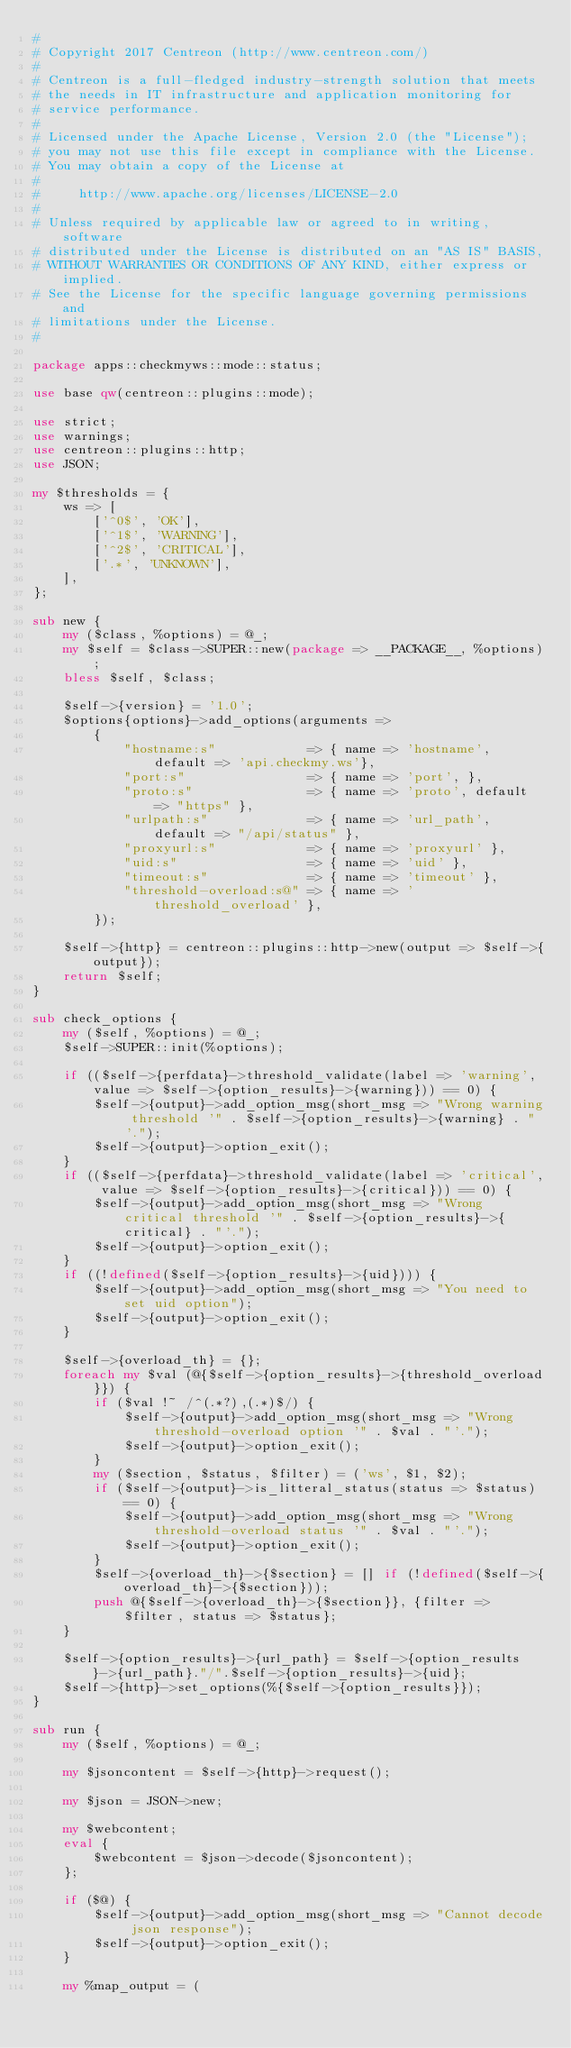Convert code to text. <code><loc_0><loc_0><loc_500><loc_500><_Perl_>#
# Copyright 2017 Centreon (http://www.centreon.com/)
#
# Centreon is a full-fledged industry-strength solution that meets
# the needs in IT infrastructure and application monitoring for
# service performance.
#
# Licensed under the Apache License, Version 2.0 (the "License");
# you may not use this file except in compliance with the License.
# You may obtain a copy of the License at
#
#     http://www.apache.org/licenses/LICENSE-2.0
#
# Unless required by applicable law or agreed to in writing, software
# distributed under the License is distributed on an "AS IS" BASIS,
# WITHOUT WARRANTIES OR CONDITIONS OF ANY KIND, either express or implied.
# See the License for the specific language governing permissions and
# limitations under the License.
#

package apps::checkmyws::mode::status;

use base qw(centreon::plugins::mode);

use strict;
use warnings;
use centreon::plugins::http;
use JSON;

my $thresholds = {
    ws => [
        ['^0$', 'OK'],
        ['^1$', 'WARNING'],
        ['^2$', 'CRITICAL'],
        ['.*', 'UNKNOWN'],
    ],
};

sub new {
    my ($class, %options) = @_;
    my $self = $class->SUPER::new(package => __PACKAGE__, %options);
    bless $self, $class;

    $self->{version} = '1.0';
    $options{options}->add_options(arguments =>
        {
            "hostname:s"            => { name => 'hostname', default => 'api.checkmy.ws'},
            "port:s"                => { name => 'port', },
            "proto:s"               => { name => 'proto', default => "https" },
            "urlpath:s"             => { name => 'url_path', default => "/api/status" },
            "proxyurl:s"            => { name => 'proxyurl' },
            "uid:s"                 => { name => 'uid' },
            "timeout:s"             => { name => 'timeout' },
            "threshold-overload:s@" => { name => 'threshold_overload' },
        });

    $self->{http} = centreon::plugins::http->new(output => $self->{output});
    return $self;
}

sub check_options {
    my ($self, %options) = @_;
    $self->SUPER::init(%options);

    if (($self->{perfdata}->threshold_validate(label => 'warning', value => $self->{option_results}->{warning})) == 0) {
        $self->{output}->add_option_msg(short_msg => "Wrong warning threshold '" . $self->{option_results}->{warning} . "'.");
        $self->{output}->option_exit();
    }
    if (($self->{perfdata}->threshold_validate(label => 'critical', value => $self->{option_results}->{critical})) == 0) {
        $self->{output}->add_option_msg(short_msg => "Wrong critical threshold '" . $self->{option_results}->{critical} . "'.");
        $self->{output}->option_exit();
    }
    if ((!defined($self->{option_results}->{uid}))) {
        $self->{output}->add_option_msg(short_msg => "You need to set uid option");
        $self->{output}->option_exit();
    }
    
    $self->{overload_th} = {};
    foreach my $val (@{$self->{option_results}->{threshold_overload}}) {
        if ($val !~ /^(.*?),(.*)$/) {
            $self->{output}->add_option_msg(short_msg => "Wrong threshold-overload option '" . $val . "'.");
            $self->{output}->option_exit();
        }
        my ($section, $status, $filter) = ('ws', $1, $2);
        if ($self->{output}->is_litteral_status(status => $status) == 0) {
            $self->{output}->add_option_msg(short_msg => "Wrong threshold-overload status '" . $val . "'.");
            $self->{output}->option_exit();
        }
        $self->{overload_th}->{$section} = [] if (!defined($self->{overload_th}->{$section}));
        push @{$self->{overload_th}->{$section}}, {filter => $filter, status => $status};
    }
    
    $self->{option_results}->{url_path} = $self->{option_results}->{url_path}."/".$self->{option_results}->{uid};
    $self->{http}->set_options(%{$self->{option_results}});
}

sub run {
    my ($self, %options) = @_;

    my $jsoncontent = $self->{http}->request();

    my $json = JSON->new;

    my $webcontent;
    eval {
        $webcontent = $json->decode($jsoncontent);
    };

    if ($@) {
        $self->{output}->add_option_msg(short_msg => "Cannot decode json response");
        $self->{output}->option_exit();
    }

    my %map_output = (</code> 